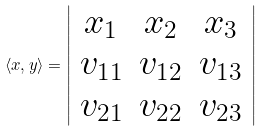Convert formula to latex. <formula><loc_0><loc_0><loc_500><loc_500>\langle x , y \rangle = \left | \begin{array} { c c c } x _ { 1 } & x _ { 2 } & x _ { 3 } \\ v _ { 1 1 } & v _ { 1 2 } & v _ { 1 3 } \\ v _ { 2 1 } & v _ { 2 2 } & v _ { 2 3 } \end{array} \right |</formula> 